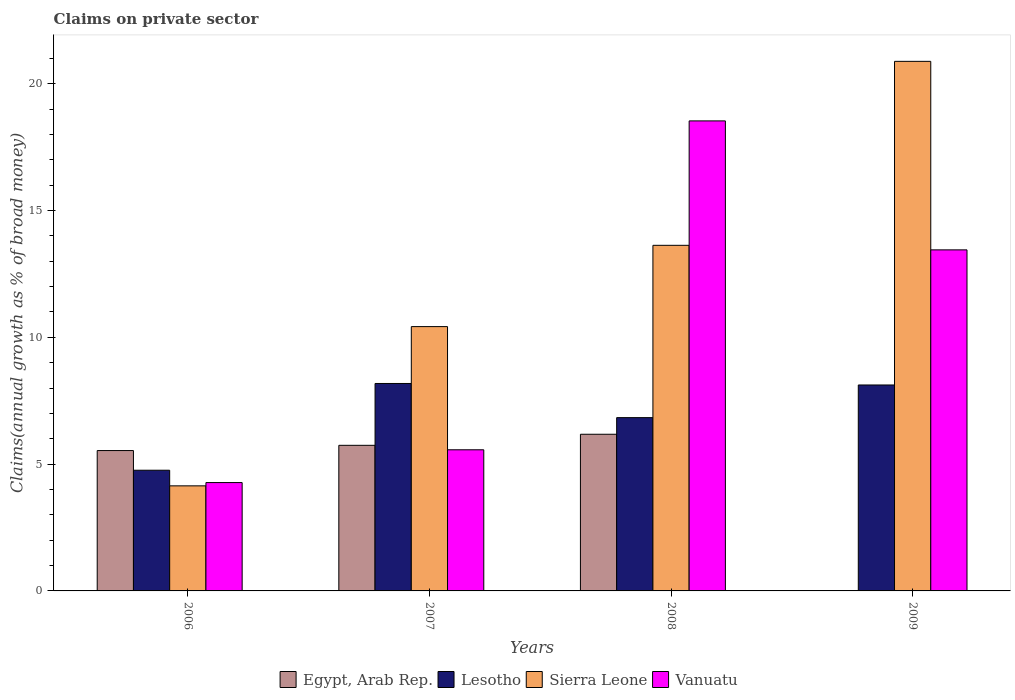How many different coloured bars are there?
Give a very brief answer. 4. How many groups of bars are there?
Your answer should be very brief. 4. Are the number of bars per tick equal to the number of legend labels?
Keep it short and to the point. No. Are the number of bars on each tick of the X-axis equal?
Your response must be concise. No. How many bars are there on the 1st tick from the right?
Provide a short and direct response. 3. What is the label of the 1st group of bars from the left?
Give a very brief answer. 2006. What is the percentage of broad money claimed on private sector in Vanuatu in 2009?
Your answer should be very brief. 13.45. Across all years, what is the maximum percentage of broad money claimed on private sector in Vanuatu?
Ensure brevity in your answer.  18.54. Across all years, what is the minimum percentage of broad money claimed on private sector in Egypt, Arab Rep.?
Your answer should be compact. 0. In which year was the percentage of broad money claimed on private sector in Egypt, Arab Rep. maximum?
Your response must be concise. 2008. What is the total percentage of broad money claimed on private sector in Egypt, Arab Rep. in the graph?
Offer a terse response. 17.46. What is the difference between the percentage of broad money claimed on private sector in Sierra Leone in 2007 and that in 2009?
Provide a short and direct response. -10.46. What is the difference between the percentage of broad money claimed on private sector in Egypt, Arab Rep. in 2009 and the percentage of broad money claimed on private sector in Vanuatu in 2006?
Offer a terse response. -4.27. What is the average percentage of broad money claimed on private sector in Egypt, Arab Rep. per year?
Keep it short and to the point. 4.36. In the year 2006, what is the difference between the percentage of broad money claimed on private sector in Egypt, Arab Rep. and percentage of broad money claimed on private sector in Vanuatu?
Offer a very short reply. 1.26. What is the ratio of the percentage of broad money claimed on private sector in Egypt, Arab Rep. in 2007 to that in 2008?
Provide a short and direct response. 0.93. What is the difference between the highest and the second highest percentage of broad money claimed on private sector in Egypt, Arab Rep.?
Your response must be concise. 0.44. What is the difference between the highest and the lowest percentage of broad money claimed on private sector in Sierra Leone?
Your answer should be very brief. 16.74. Is it the case that in every year, the sum of the percentage of broad money claimed on private sector in Egypt, Arab Rep. and percentage of broad money claimed on private sector in Sierra Leone is greater than the sum of percentage of broad money claimed on private sector in Lesotho and percentage of broad money claimed on private sector in Vanuatu?
Your answer should be very brief. No. How many bars are there?
Provide a short and direct response. 15. Are all the bars in the graph horizontal?
Ensure brevity in your answer.  No. Are the values on the major ticks of Y-axis written in scientific E-notation?
Your response must be concise. No. Where does the legend appear in the graph?
Your answer should be compact. Bottom center. How many legend labels are there?
Provide a succinct answer. 4. How are the legend labels stacked?
Offer a very short reply. Horizontal. What is the title of the graph?
Your response must be concise. Claims on private sector. Does "Nigeria" appear as one of the legend labels in the graph?
Keep it short and to the point. No. What is the label or title of the X-axis?
Offer a very short reply. Years. What is the label or title of the Y-axis?
Provide a short and direct response. Claims(annual growth as % of broad money). What is the Claims(annual growth as % of broad money) of Egypt, Arab Rep. in 2006?
Keep it short and to the point. 5.54. What is the Claims(annual growth as % of broad money) of Lesotho in 2006?
Your response must be concise. 4.76. What is the Claims(annual growth as % of broad money) in Sierra Leone in 2006?
Ensure brevity in your answer.  4.14. What is the Claims(annual growth as % of broad money) of Vanuatu in 2006?
Keep it short and to the point. 4.27. What is the Claims(annual growth as % of broad money) of Egypt, Arab Rep. in 2007?
Your answer should be compact. 5.74. What is the Claims(annual growth as % of broad money) in Lesotho in 2007?
Make the answer very short. 8.18. What is the Claims(annual growth as % of broad money) of Sierra Leone in 2007?
Provide a short and direct response. 10.42. What is the Claims(annual growth as % of broad money) of Vanuatu in 2007?
Keep it short and to the point. 5.57. What is the Claims(annual growth as % of broad money) in Egypt, Arab Rep. in 2008?
Provide a succinct answer. 6.18. What is the Claims(annual growth as % of broad money) in Lesotho in 2008?
Your answer should be compact. 6.83. What is the Claims(annual growth as % of broad money) of Sierra Leone in 2008?
Ensure brevity in your answer.  13.63. What is the Claims(annual growth as % of broad money) of Vanuatu in 2008?
Offer a terse response. 18.54. What is the Claims(annual growth as % of broad money) in Lesotho in 2009?
Provide a short and direct response. 8.12. What is the Claims(annual growth as % of broad money) of Sierra Leone in 2009?
Make the answer very short. 20.88. What is the Claims(annual growth as % of broad money) of Vanuatu in 2009?
Offer a terse response. 13.45. Across all years, what is the maximum Claims(annual growth as % of broad money) of Egypt, Arab Rep.?
Make the answer very short. 6.18. Across all years, what is the maximum Claims(annual growth as % of broad money) in Lesotho?
Make the answer very short. 8.18. Across all years, what is the maximum Claims(annual growth as % of broad money) of Sierra Leone?
Provide a short and direct response. 20.88. Across all years, what is the maximum Claims(annual growth as % of broad money) of Vanuatu?
Your answer should be very brief. 18.54. Across all years, what is the minimum Claims(annual growth as % of broad money) in Egypt, Arab Rep.?
Give a very brief answer. 0. Across all years, what is the minimum Claims(annual growth as % of broad money) in Lesotho?
Ensure brevity in your answer.  4.76. Across all years, what is the minimum Claims(annual growth as % of broad money) in Sierra Leone?
Keep it short and to the point. 4.14. Across all years, what is the minimum Claims(annual growth as % of broad money) in Vanuatu?
Offer a terse response. 4.27. What is the total Claims(annual growth as % of broad money) of Egypt, Arab Rep. in the graph?
Provide a short and direct response. 17.46. What is the total Claims(annual growth as % of broad money) of Lesotho in the graph?
Give a very brief answer. 27.9. What is the total Claims(annual growth as % of broad money) in Sierra Leone in the graph?
Your response must be concise. 49.08. What is the total Claims(annual growth as % of broad money) of Vanuatu in the graph?
Offer a terse response. 41.83. What is the difference between the Claims(annual growth as % of broad money) in Egypt, Arab Rep. in 2006 and that in 2007?
Offer a very short reply. -0.21. What is the difference between the Claims(annual growth as % of broad money) of Lesotho in 2006 and that in 2007?
Give a very brief answer. -3.42. What is the difference between the Claims(annual growth as % of broad money) of Sierra Leone in 2006 and that in 2007?
Provide a short and direct response. -6.28. What is the difference between the Claims(annual growth as % of broad money) in Vanuatu in 2006 and that in 2007?
Keep it short and to the point. -1.29. What is the difference between the Claims(annual growth as % of broad money) of Egypt, Arab Rep. in 2006 and that in 2008?
Offer a very short reply. -0.64. What is the difference between the Claims(annual growth as % of broad money) of Lesotho in 2006 and that in 2008?
Make the answer very short. -2.07. What is the difference between the Claims(annual growth as % of broad money) of Sierra Leone in 2006 and that in 2008?
Keep it short and to the point. -9.49. What is the difference between the Claims(annual growth as % of broad money) in Vanuatu in 2006 and that in 2008?
Keep it short and to the point. -14.26. What is the difference between the Claims(annual growth as % of broad money) of Lesotho in 2006 and that in 2009?
Give a very brief answer. -3.36. What is the difference between the Claims(annual growth as % of broad money) in Sierra Leone in 2006 and that in 2009?
Your answer should be very brief. -16.74. What is the difference between the Claims(annual growth as % of broad money) of Vanuatu in 2006 and that in 2009?
Keep it short and to the point. -9.18. What is the difference between the Claims(annual growth as % of broad money) of Egypt, Arab Rep. in 2007 and that in 2008?
Give a very brief answer. -0.44. What is the difference between the Claims(annual growth as % of broad money) in Lesotho in 2007 and that in 2008?
Give a very brief answer. 1.35. What is the difference between the Claims(annual growth as % of broad money) of Sierra Leone in 2007 and that in 2008?
Your answer should be very brief. -3.21. What is the difference between the Claims(annual growth as % of broad money) in Vanuatu in 2007 and that in 2008?
Offer a very short reply. -12.97. What is the difference between the Claims(annual growth as % of broad money) of Lesotho in 2007 and that in 2009?
Offer a terse response. 0.06. What is the difference between the Claims(annual growth as % of broad money) in Sierra Leone in 2007 and that in 2009?
Offer a terse response. -10.46. What is the difference between the Claims(annual growth as % of broad money) in Vanuatu in 2007 and that in 2009?
Keep it short and to the point. -7.88. What is the difference between the Claims(annual growth as % of broad money) of Lesotho in 2008 and that in 2009?
Offer a terse response. -1.29. What is the difference between the Claims(annual growth as % of broad money) in Sierra Leone in 2008 and that in 2009?
Offer a very short reply. -7.25. What is the difference between the Claims(annual growth as % of broad money) in Vanuatu in 2008 and that in 2009?
Provide a succinct answer. 5.09. What is the difference between the Claims(annual growth as % of broad money) in Egypt, Arab Rep. in 2006 and the Claims(annual growth as % of broad money) in Lesotho in 2007?
Ensure brevity in your answer.  -2.65. What is the difference between the Claims(annual growth as % of broad money) of Egypt, Arab Rep. in 2006 and the Claims(annual growth as % of broad money) of Sierra Leone in 2007?
Your answer should be compact. -4.89. What is the difference between the Claims(annual growth as % of broad money) of Egypt, Arab Rep. in 2006 and the Claims(annual growth as % of broad money) of Vanuatu in 2007?
Offer a very short reply. -0.03. What is the difference between the Claims(annual growth as % of broad money) of Lesotho in 2006 and the Claims(annual growth as % of broad money) of Sierra Leone in 2007?
Give a very brief answer. -5.66. What is the difference between the Claims(annual growth as % of broad money) in Lesotho in 2006 and the Claims(annual growth as % of broad money) in Vanuatu in 2007?
Make the answer very short. -0.81. What is the difference between the Claims(annual growth as % of broad money) of Sierra Leone in 2006 and the Claims(annual growth as % of broad money) of Vanuatu in 2007?
Provide a short and direct response. -1.42. What is the difference between the Claims(annual growth as % of broad money) of Egypt, Arab Rep. in 2006 and the Claims(annual growth as % of broad money) of Lesotho in 2008?
Offer a very short reply. -1.3. What is the difference between the Claims(annual growth as % of broad money) in Egypt, Arab Rep. in 2006 and the Claims(annual growth as % of broad money) in Sierra Leone in 2008?
Ensure brevity in your answer.  -8.09. What is the difference between the Claims(annual growth as % of broad money) in Egypt, Arab Rep. in 2006 and the Claims(annual growth as % of broad money) in Vanuatu in 2008?
Your answer should be compact. -13. What is the difference between the Claims(annual growth as % of broad money) in Lesotho in 2006 and the Claims(annual growth as % of broad money) in Sierra Leone in 2008?
Ensure brevity in your answer.  -8.87. What is the difference between the Claims(annual growth as % of broad money) of Lesotho in 2006 and the Claims(annual growth as % of broad money) of Vanuatu in 2008?
Ensure brevity in your answer.  -13.78. What is the difference between the Claims(annual growth as % of broad money) of Sierra Leone in 2006 and the Claims(annual growth as % of broad money) of Vanuatu in 2008?
Make the answer very short. -14.39. What is the difference between the Claims(annual growth as % of broad money) in Egypt, Arab Rep. in 2006 and the Claims(annual growth as % of broad money) in Lesotho in 2009?
Your answer should be compact. -2.59. What is the difference between the Claims(annual growth as % of broad money) in Egypt, Arab Rep. in 2006 and the Claims(annual growth as % of broad money) in Sierra Leone in 2009?
Your answer should be compact. -15.35. What is the difference between the Claims(annual growth as % of broad money) of Egypt, Arab Rep. in 2006 and the Claims(annual growth as % of broad money) of Vanuatu in 2009?
Offer a terse response. -7.91. What is the difference between the Claims(annual growth as % of broad money) in Lesotho in 2006 and the Claims(annual growth as % of broad money) in Sierra Leone in 2009?
Offer a very short reply. -16.13. What is the difference between the Claims(annual growth as % of broad money) of Lesotho in 2006 and the Claims(annual growth as % of broad money) of Vanuatu in 2009?
Your response must be concise. -8.69. What is the difference between the Claims(annual growth as % of broad money) in Sierra Leone in 2006 and the Claims(annual growth as % of broad money) in Vanuatu in 2009?
Your answer should be very brief. -9.31. What is the difference between the Claims(annual growth as % of broad money) of Egypt, Arab Rep. in 2007 and the Claims(annual growth as % of broad money) of Lesotho in 2008?
Your answer should be very brief. -1.09. What is the difference between the Claims(annual growth as % of broad money) of Egypt, Arab Rep. in 2007 and the Claims(annual growth as % of broad money) of Sierra Leone in 2008?
Give a very brief answer. -7.89. What is the difference between the Claims(annual growth as % of broad money) of Egypt, Arab Rep. in 2007 and the Claims(annual growth as % of broad money) of Vanuatu in 2008?
Provide a succinct answer. -12.79. What is the difference between the Claims(annual growth as % of broad money) of Lesotho in 2007 and the Claims(annual growth as % of broad money) of Sierra Leone in 2008?
Offer a very short reply. -5.45. What is the difference between the Claims(annual growth as % of broad money) of Lesotho in 2007 and the Claims(annual growth as % of broad money) of Vanuatu in 2008?
Keep it short and to the point. -10.36. What is the difference between the Claims(annual growth as % of broad money) in Sierra Leone in 2007 and the Claims(annual growth as % of broad money) in Vanuatu in 2008?
Your answer should be compact. -8.11. What is the difference between the Claims(annual growth as % of broad money) in Egypt, Arab Rep. in 2007 and the Claims(annual growth as % of broad money) in Lesotho in 2009?
Make the answer very short. -2.38. What is the difference between the Claims(annual growth as % of broad money) of Egypt, Arab Rep. in 2007 and the Claims(annual growth as % of broad money) of Sierra Leone in 2009?
Keep it short and to the point. -15.14. What is the difference between the Claims(annual growth as % of broad money) in Egypt, Arab Rep. in 2007 and the Claims(annual growth as % of broad money) in Vanuatu in 2009?
Offer a terse response. -7.71. What is the difference between the Claims(annual growth as % of broad money) of Lesotho in 2007 and the Claims(annual growth as % of broad money) of Sierra Leone in 2009?
Offer a very short reply. -12.7. What is the difference between the Claims(annual growth as % of broad money) in Lesotho in 2007 and the Claims(annual growth as % of broad money) in Vanuatu in 2009?
Keep it short and to the point. -5.27. What is the difference between the Claims(annual growth as % of broad money) in Sierra Leone in 2007 and the Claims(annual growth as % of broad money) in Vanuatu in 2009?
Your response must be concise. -3.03. What is the difference between the Claims(annual growth as % of broad money) in Egypt, Arab Rep. in 2008 and the Claims(annual growth as % of broad money) in Lesotho in 2009?
Offer a very short reply. -1.94. What is the difference between the Claims(annual growth as % of broad money) in Egypt, Arab Rep. in 2008 and the Claims(annual growth as % of broad money) in Sierra Leone in 2009?
Your response must be concise. -14.71. What is the difference between the Claims(annual growth as % of broad money) in Egypt, Arab Rep. in 2008 and the Claims(annual growth as % of broad money) in Vanuatu in 2009?
Offer a very short reply. -7.27. What is the difference between the Claims(annual growth as % of broad money) of Lesotho in 2008 and the Claims(annual growth as % of broad money) of Sierra Leone in 2009?
Ensure brevity in your answer.  -14.05. What is the difference between the Claims(annual growth as % of broad money) of Lesotho in 2008 and the Claims(annual growth as % of broad money) of Vanuatu in 2009?
Keep it short and to the point. -6.62. What is the difference between the Claims(annual growth as % of broad money) in Sierra Leone in 2008 and the Claims(annual growth as % of broad money) in Vanuatu in 2009?
Give a very brief answer. 0.18. What is the average Claims(annual growth as % of broad money) in Egypt, Arab Rep. per year?
Provide a short and direct response. 4.36. What is the average Claims(annual growth as % of broad money) in Lesotho per year?
Give a very brief answer. 6.97. What is the average Claims(annual growth as % of broad money) of Sierra Leone per year?
Keep it short and to the point. 12.27. What is the average Claims(annual growth as % of broad money) in Vanuatu per year?
Your answer should be compact. 10.46. In the year 2006, what is the difference between the Claims(annual growth as % of broad money) in Egypt, Arab Rep. and Claims(annual growth as % of broad money) in Lesotho?
Your answer should be compact. 0.78. In the year 2006, what is the difference between the Claims(annual growth as % of broad money) in Egypt, Arab Rep. and Claims(annual growth as % of broad money) in Sierra Leone?
Make the answer very short. 1.39. In the year 2006, what is the difference between the Claims(annual growth as % of broad money) of Egypt, Arab Rep. and Claims(annual growth as % of broad money) of Vanuatu?
Give a very brief answer. 1.26. In the year 2006, what is the difference between the Claims(annual growth as % of broad money) of Lesotho and Claims(annual growth as % of broad money) of Sierra Leone?
Keep it short and to the point. 0.62. In the year 2006, what is the difference between the Claims(annual growth as % of broad money) of Lesotho and Claims(annual growth as % of broad money) of Vanuatu?
Your answer should be compact. 0.49. In the year 2006, what is the difference between the Claims(annual growth as % of broad money) of Sierra Leone and Claims(annual growth as % of broad money) of Vanuatu?
Offer a terse response. -0.13. In the year 2007, what is the difference between the Claims(annual growth as % of broad money) of Egypt, Arab Rep. and Claims(annual growth as % of broad money) of Lesotho?
Your response must be concise. -2.44. In the year 2007, what is the difference between the Claims(annual growth as % of broad money) in Egypt, Arab Rep. and Claims(annual growth as % of broad money) in Sierra Leone?
Offer a very short reply. -4.68. In the year 2007, what is the difference between the Claims(annual growth as % of broad money) in Egypt, Arab Rep. and Claims(annual growth as % of broad money) in Vanuatu?
Your answer should be very brief. 0.18. In the year 2007, what is the difference between the Claims(annual growth as % of broad money) of Lesotho and Claims(annual growth as % of broad money) of Sierra Leone?
Offer a terse response. -2.24. In the year 2007, what is the difference between the Claims(annual growth as % of broad money) in Lesotho and Claims(annual growth as % of broad money) in Vanuatu?
Your answer should be compact. 2.61. In the year 2007, what is the difference between the Claims(annual growth as % of broad money) of Sierra Leone and Claims(annual growth as % of broad money) of Vanuatu?
Offer a terse response. 4.86. In the year 2008, what is the difference between the Claims(annual growth as % of broad money) in Egypt, Arab Rep. and Claims(annual growth as % of broad money) in Lesotho?
Ensure brevity in your answer.  -0.66. In the year 2008, what is the difference between the Claims(annual growth as % of broad money) in Egypt, Arab Rep. and Claims(annual growth as % of broad money) in Sierra Leone?
Your answer should be compact. -7.45. In the year 2008, what is the difference between the Claims(annual growth as % of broad money) in Egypt, Arab Rep. and Claims(annual growth as % of broad money) in Vanuatu?
Ensure brevity in your answer.  -12.36. In the year 2008, what is the difference between the Claims(annual growth as % of broad money) in Lesotho and Claims(annual growth as % of broad money) in Sierra Leone?
Your response must be concise. -6.8. In the year 2008, what is the difference between the Claims(annual growth as % of broad money) in Lesotho and Claims(annual growth as % of broad money) in Vanuatu?
Ensure brevity in your answer.  -11.7. In the year 2008, what is the difference between the Claims(annual growth as % of broad money) in Sierra Leone and Claims(annual growth as % of broad money) in Vanuatu?
Offer a very short reply. -4.91. In the year 2009, what is the difference between the Claims(annual growth as % of broad money) of Lesotho and Claims(annual growth as % of broad money) of Sierra Leone?
Your response must be concise. -12.76. In the year 2009, what is the difference between the Claims(annual growth as % of broad money) of Lesotho and Claims(annual growth as % of broad money) of Vanuatu?
Provide a short and direct response. -5.33. In the year 2009, what is the difference between the Claims(annual growth as % of broad money) in Sierra Leone and Claims(annual growth as % of broad money) in Vanuatu?
Make the answer very short. 7.43. What is the ratio of the Claims(annual growth as % of broad money) of Egypt, Arab Rep. in 2006 to that in 2007?
Your answer should be compact. 0.96. What is the ratio of the Claims(annual growth as % of broad money) in Lesotho in 2006 to that in 2007?
Provide a succinct answer. 0.58. What is the ratio of the Claims(annual growth as % of broad money) in Sierra Leone in 2006 to that in 2007?
Offer a very short reply. 0.4. What is the ratio of the Claims(annual growth as % of broad money) of Vanuatu in 2006 to that in 2007?
Ensure brevity in your answer.  0.77. What is the ratio of the Claims(annual growth as % of broad money) in Egypt, Arab Rep. in 2006 to that in 2008?
Your answer should be very brief. 0.9. What is the ratio of the Claims(annual growth as % of broad money) of Lesotho in 2006 to that in 2008?
Provide a short and direct response. 0.7. What is the ratio of the Claims(annual growth as % of broad money) of Sierra Leone in 2006 to that in 2008?
Your answer should be very brief. 0.3. What is the ratio of the Claims(annual growth as % of broad money) in Vanuatu in 2006 to that in 2008?
Keep it short and to the point. 0.23. What is the ratio of the Claims(annual growth as % of broad money) in Lesotho in 2006 to that in 2009?
Ensure brevity in your answer.  0.59. What is the ratio of the Claims(annual growth as % of broad money) of Sierra Leone in 2006 to that in 2009?
Provide a short and direct response. 0.2. What is the ratio of the Claims(annual growth as % of broad money) of Vanuatu in 2006 to that in 2009?
Make the answer very short. 0.32. What is the ratio of the Claims(annual growth as % of broad money) of Egypt, Arab Rep. in 2007 to that in 2008?
Your response must be concise. 0.93. What is the ratio of the Claims(annual growth as % of broad money) in Lesotho in 2007 to that in 2008?
Ensure brevity in your answer.  1.2. What is the ratio of the Claims(annual growth as % of broad money) of Sierra Leone in 2007 to that in 2008?
Your answer should be compact. 0.76. What is the ratio of the Claims(annual growth as % of broad money) of Vanuatu in 2007 to that in 2008?
Your response must be concise. 0.3. What is the ratio of the Claims(annual growth as % of broad money) in Lesotho in 2007 to that in 2009?
Give a very brief answer. 1.01. What is the ratio of the Claims(annual growth as % of broad money) in Sierra Leone in 2007 to that in 2009?
Your response must be concise. 0.5. What is the ratio of the Claims(annual growth as % of broad money) of Vanuatu in 2007 to that in 2009?
Offer a very short reply. 0.41. What is the ratio of the Claims(annual growth as % of broad money) of Lesotho in 2008 to that in 2009?
Offer a terse response. 0.84. What is the ratio of the Claims(annual growth as % of broad money) in Sierra Leone in 2008 to that in 2009?
Make the answer very short. 0.65. What is the ratio of the Claims(annual growth as % of broad money) of Vanuatu in 2008 to that in 2009?
Offer a terse response. 1.38. What is the difference between the highest and the second highest Claims(annual growth as % of broad money) in Egypt, Arab Rep.?
Your response must be concise. 0.44. What is the difference between the highest and the second highest Claims(annual growth as % of broad money) in Lesotho?
Give a very brief answer. 0.06. What is the difference between the highest and the second highest Claims(annual growth as % of broad money) in Sierra Leone?
Provide a short and direct response. 7.25. What is the difference between the highest and the second highest Claims(annual growth as % of broad money) in Vanuatu?
Your response must be concise. 5.09. What is the difference between the highest and the lowest Claims(annual growth as % of broad money) of Egypt, Arab Rep.?
Make the answer very short. 6.18. What is the difference between the highest and the lowest Claims(annual growth as % of broad money) of Lesotho?
Provide a short and direct response. 3.42. What is the difference between the highest and the lowest Claims(annual growth as % of broad money) of Sierra Leone?
Provide a short and direct response. 16.74. What is the difference between the highest and the lowest Claims(annual growth as % of broad money) in Vanuatu?
Offer a terse response. 14.26. 